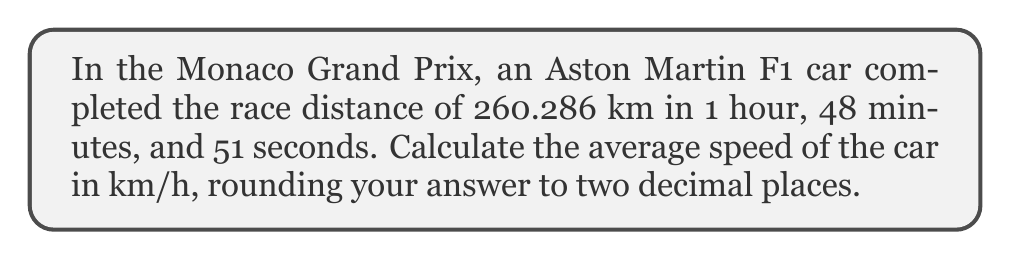Provide a solution to this math problem. To calculate the average speed, we need to use the formula:

$$ \text{Average Speed} = \frac{\text{Total Distance}}{\text{Total Time}} $$

Let's break down the problem into steps:

1) First, we need to convert the time into hours:
   1 hour, 48 minutes, and 51 seconds = 1 + (48/60) + (51/3600) hours
   $$ \text{Time in hours} = 1 + \frac{48}{60} + \frac{51}{3600} = 1.8141667 \text{ hours} $$

2) Now we have:
   Distance = 260.286 km
   Time = 1.8141667 hours

3) Applying the average speed formula:
   $$ \text{Average Speed} = \frac{260.286}{1.8141667} $$

4) Calculating:
   $$ \text{Average Speed} = 143.4733 \text{ km/h} $$

5) Rounding to two decimal places:
   $$ \text{Average Speed} \approx 143.47 \text{ km/h} $$
Answer: The average speed of the Aston Martin F1 car over the race distance is approximately 143.47 km/h. 